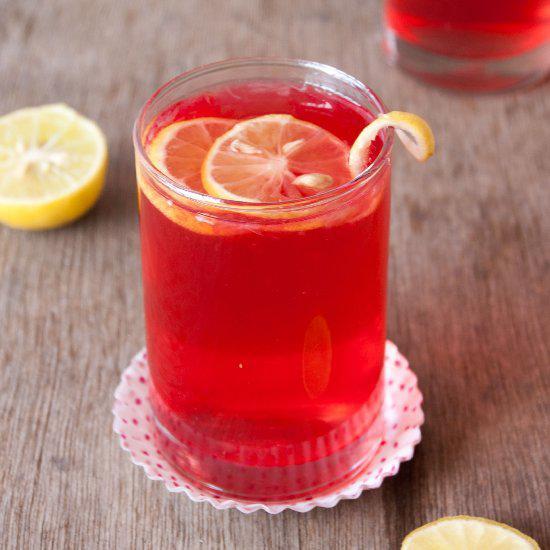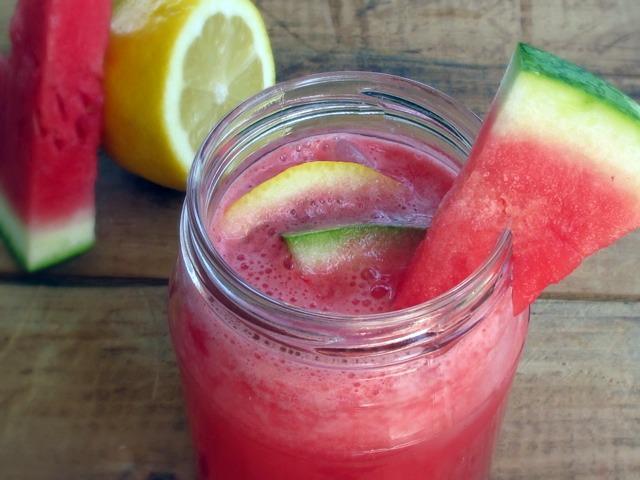The first image is the image on the left, the second image is the image on the right. Given the left and right images, does the statement "One image has a watermelon garnish on the glass." hold true? Answer yes or no. Yes. The first image is the image on the left, the second image is the image on the right. Examine the images to the left and right. Is the description "One image shows drink ingredients only, including watermelon and lemon." accurate? Answer yes or no. No. 